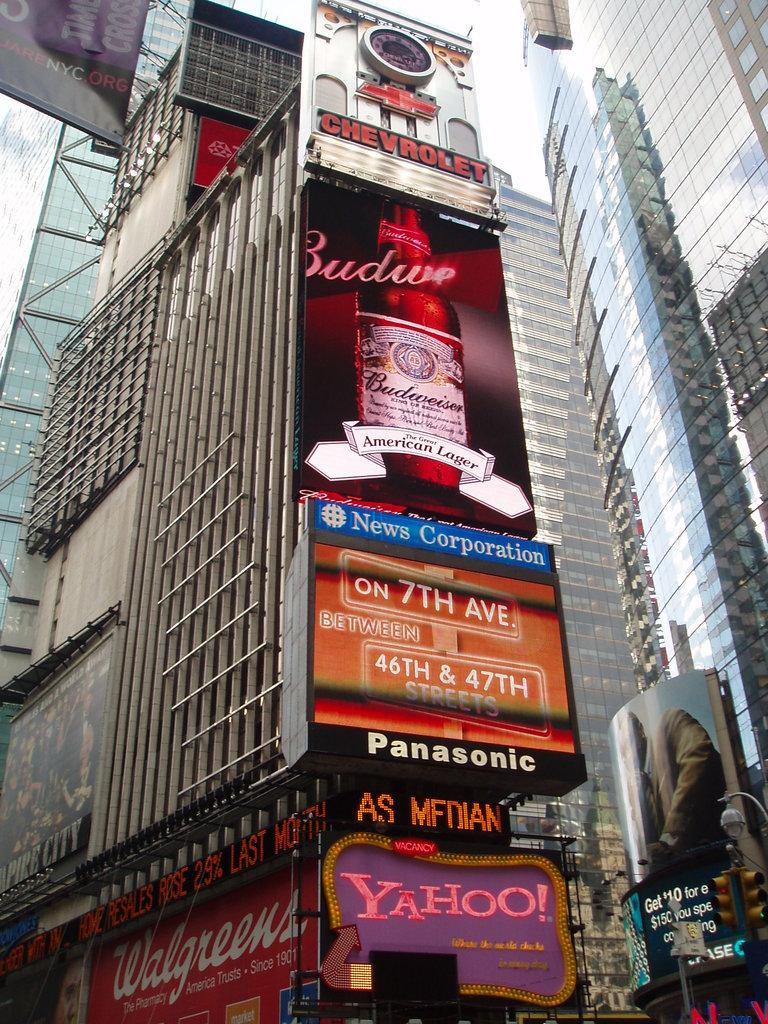What type of structures can be seen in the image? There are buildings in the image. What other objects are present in the image besides the buildings? There are boards in the image. How does the current affect the finger in the image? There is no finger or current present in the image. 